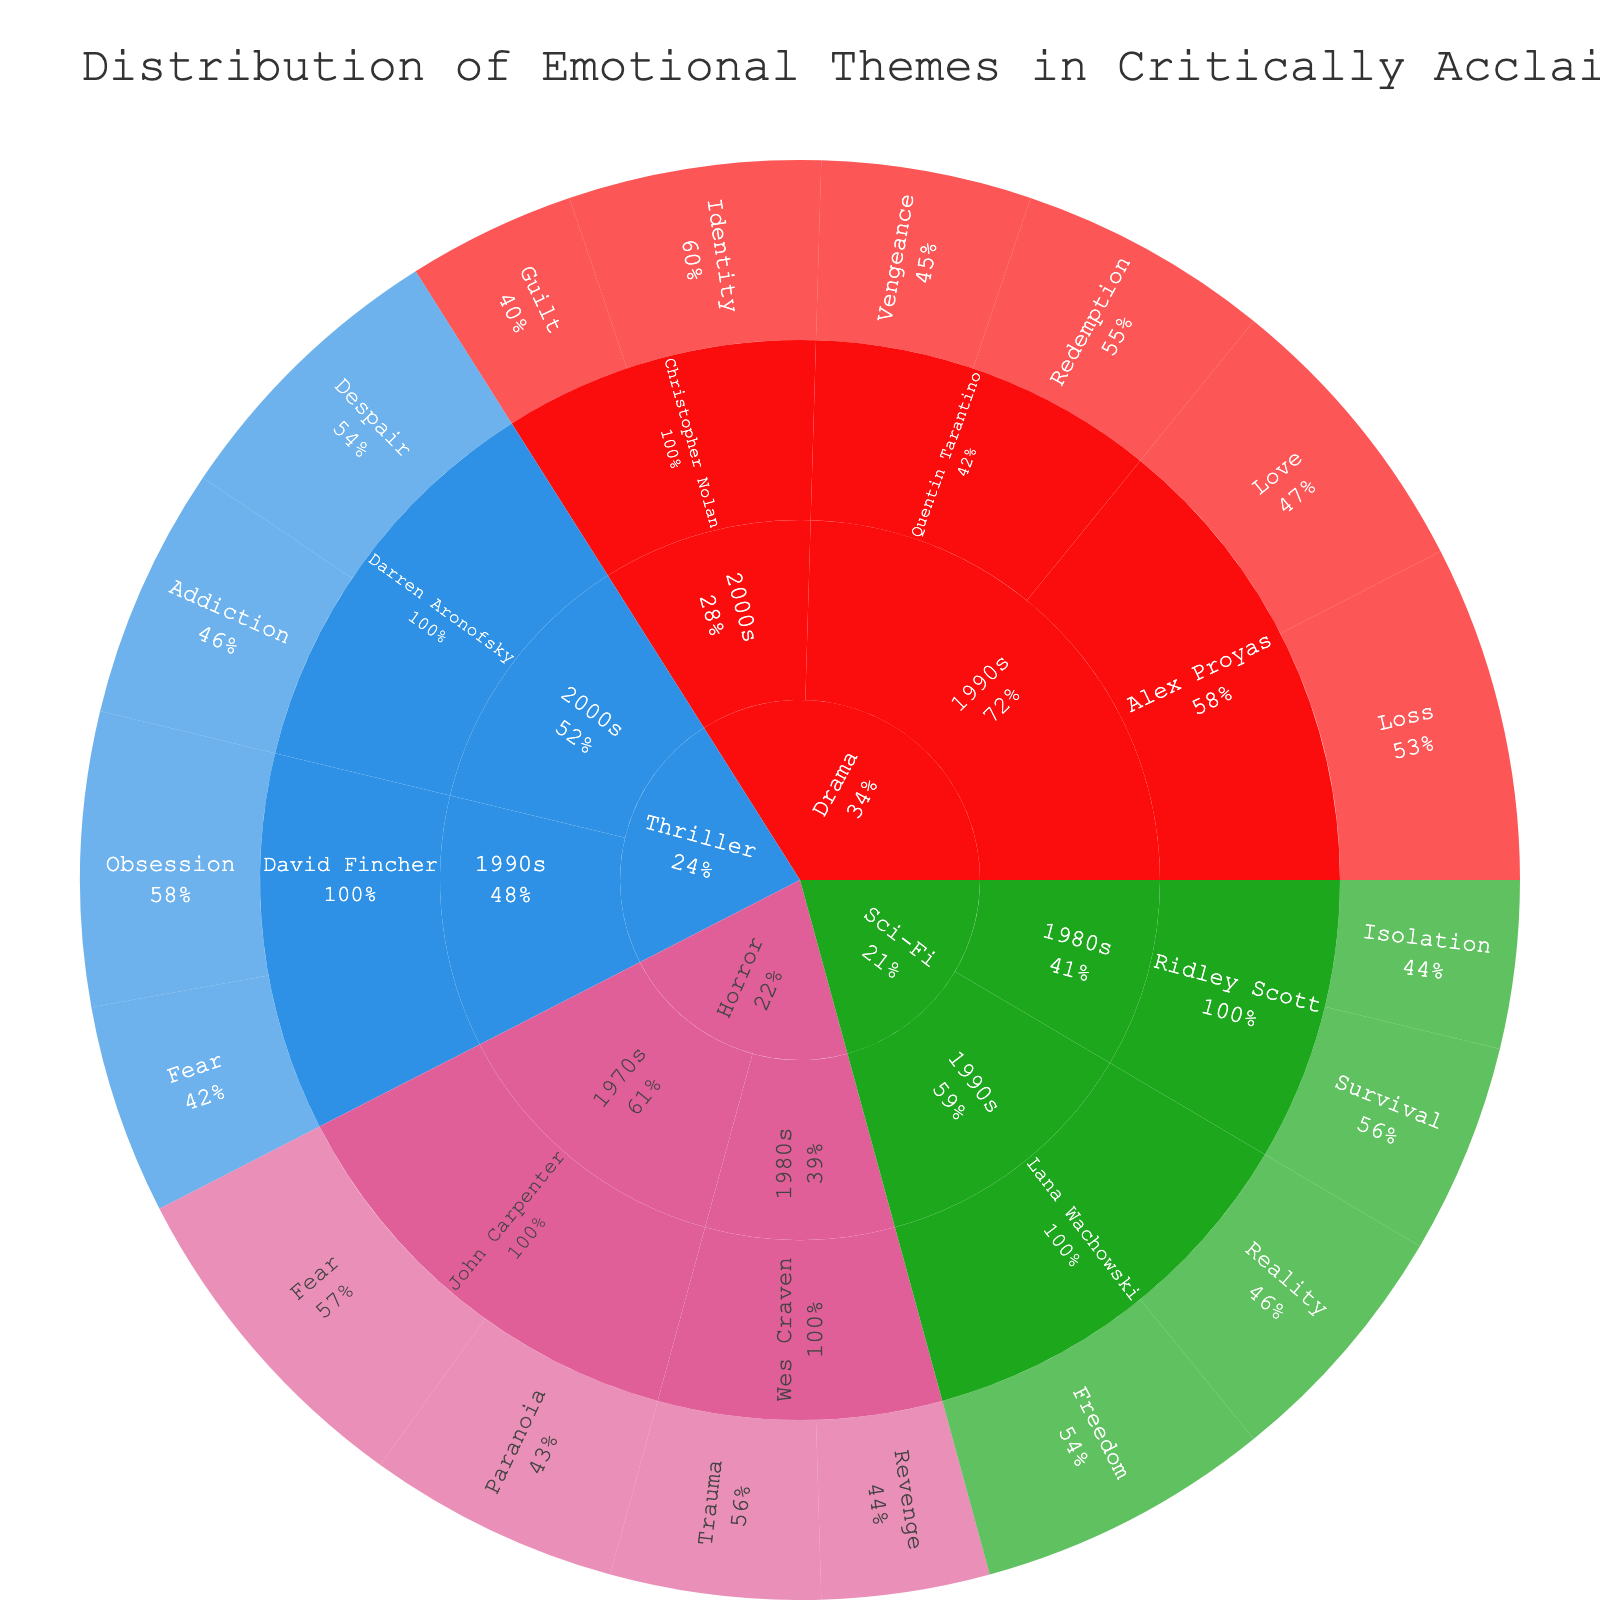How many emotional themes are explored in Quentin Tarantino's films? Quentin Tarantino's films are found under the Drama genre in the 1990s decade. He explores two emotional themes: Redemption and Vengeance.
Answer: 2 Which director in the Drama genre has incorporated the theme of identity in the 2000s? Look under the Drama genre, then navigate to the 2000s decade. The director listed for the emotional theme of Identity is Christopher Nolan.
Answer: Christopher Nolan What is the total value for emotional themes in Thriller films from the 1990s? Navigate to the Thriller genre and then to the 1990s decade. Sum the values of David Fincher's films: Obsession (35) and Fear (25). The total value is 35 + 25 = 60.
Answer: 60 Which emotional theme has the highest representation in Sci-Fi films from the 1990s? For Sci-Fi in the 1990s, check the themes listed under Lana Wachowski. Reality has a value of 30 and Freedom has a value of 35. Thus, Freedom has the highest representation.
Answer: Freedom Compare the values of the themes explored by Alex Proyas and Darren Aronofsky. Who has the higher total? Alex Proyas's values are under Drama in the 1990s: Love (35) and Loss (40), totaling 75. Darren Aronofsky's values are under Thriller in the 2000s: Addiction (30) and Despair (35), totaling 65. Therefore, Alex Proyas has a higher total.
Answer: Alex Proyas Which decade contains the highest value of emotional themes in Horror films? Navigate to the Horror genre and compare the values for each decade. The 1970s have John Carpenter's Fear (40) and Paranoia (30), totaling 70. The 1980s have Wes Craven's Trauma (25) and Revenge (20), totaling 45. The highest value is in the 1970s.
Answer: 1970s What is the total representation of emotions related to identity (identity, reality, etc.) in the Drama and Sci-Fi genres? Under Drama, we see Christopher Nolan's Identity (30). Under Sci-Fi, we have Lana Wachowski's Reality (30). Adding these values gives 30 + 30 = 60.
Answer: 60 Which genre has the most diverse range of emotional themes as indicated by the different color segments? Observe the number of unique color segments within each genre. Drama has four unique themes (different colors), Thriller has four themes, Sci-Fi has four themes, and Horror has four themes. All genres have the same range of diversity.
Answer: Drama, Thriller, Sci-Fi, Horror How does the representation of vengeance compare between the 1990s and 1980s decade films? In the 1990s, Quentin Tarantino's Vengeance has a value of 25. In the 1980s, Vengeance does not appear. Thus, Vengeance is represented only in the 1990s.
Answer: Represented only in the 1990s What's the most prominent emotional theme in John Carpenter's films? John Carpenter's films are in the Horror genre during the 1970s. The two themes are Fear (40) and Paranoia (30). Fear has the highest value at 40.
Answer: Fear 